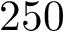Convert formula to latex. <formula><loc_0><loc_0><loc_500><loc_500>2 5 0</formula> 